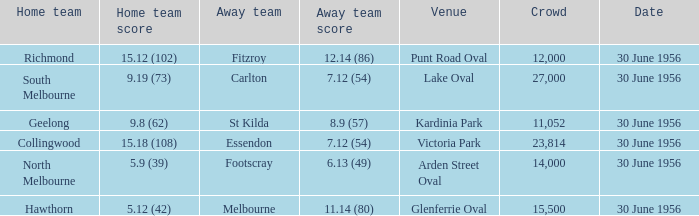What is the home team at Victoria Park with an Away team score of 7.12 (54) and more than 12,000 people? Collingwood. 